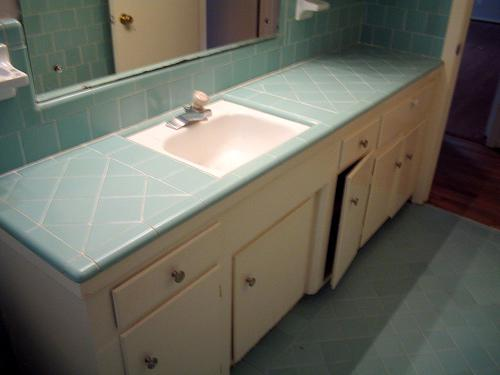Question: how was the door left?
Choices:
A. Closed.
B. Propped.
C. Shut.
D. Open.
Answer with the letter. Answer: D Question: what kind of flooring the bathroom has?
Choices:
A. Linolium.
B. Wood.
C. Tiles.
D. Checked.
Answer with the letter. Answer: C 